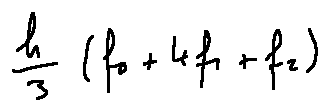Convert formula to latex. <formula><loc_0><loc_0><loc_500><loc_500>\frac { h } { 3 } ( f _ { 0 } + 4 f _ { 1 } + f _ { 2 } )</formula> 